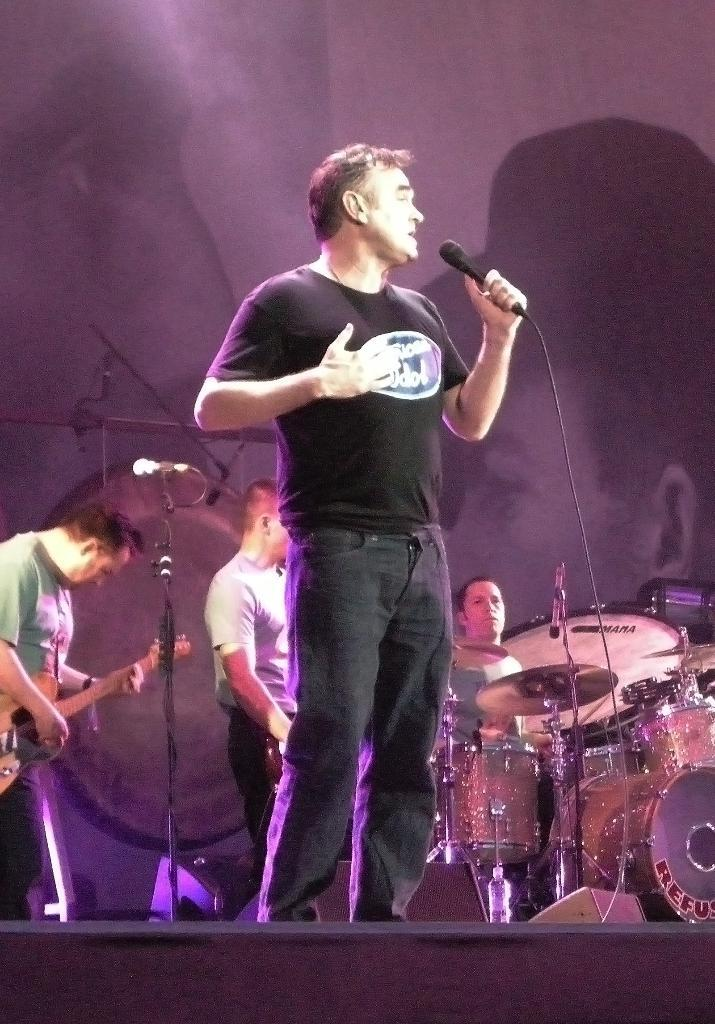Who is the main subject in the image? There is a person in the image. What is the person wearing? The person is wearing a black shirt. What is the person doing in the image? The person is standing and singing. What object is in front of the person? There is a microphone in front of the person. Are there any other people in the image? Yes, there are people playing musical instruments in the image. What type of card is the person holding in the image? There is no card present in the image. Which muscle is the person exercising while singing? The person is not exercising any muscles while singing; they are simply standing and singing. 